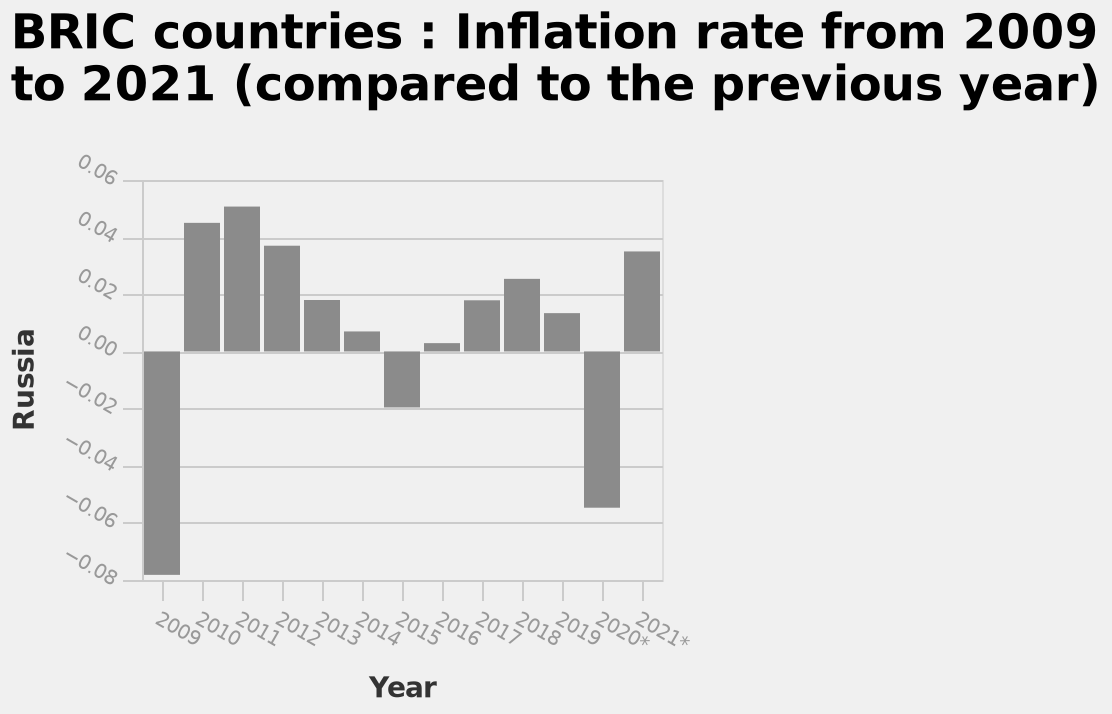<image>
What is the range of years represented on the x-axis of the bar chart? The range of years represented on the x-axis is from 2009 to 2021. Are there any specific labels mentioned on the y-axis other than Russia? No, the description only mentions the specific categorical scale for Russia on the y-axis. Can you describe the trend in inflation over the years?  The trend in inflation shows periods of increase, decrease, and subsequent increase again. How would you describe the recent fluctuations in inflation?  Inflation initially increased for a few years, then decreased for a few years, and now it is on the rise again. Which countries are included in the BRIC group? The BRIC countries include Brazil, Russia, India, and China. 